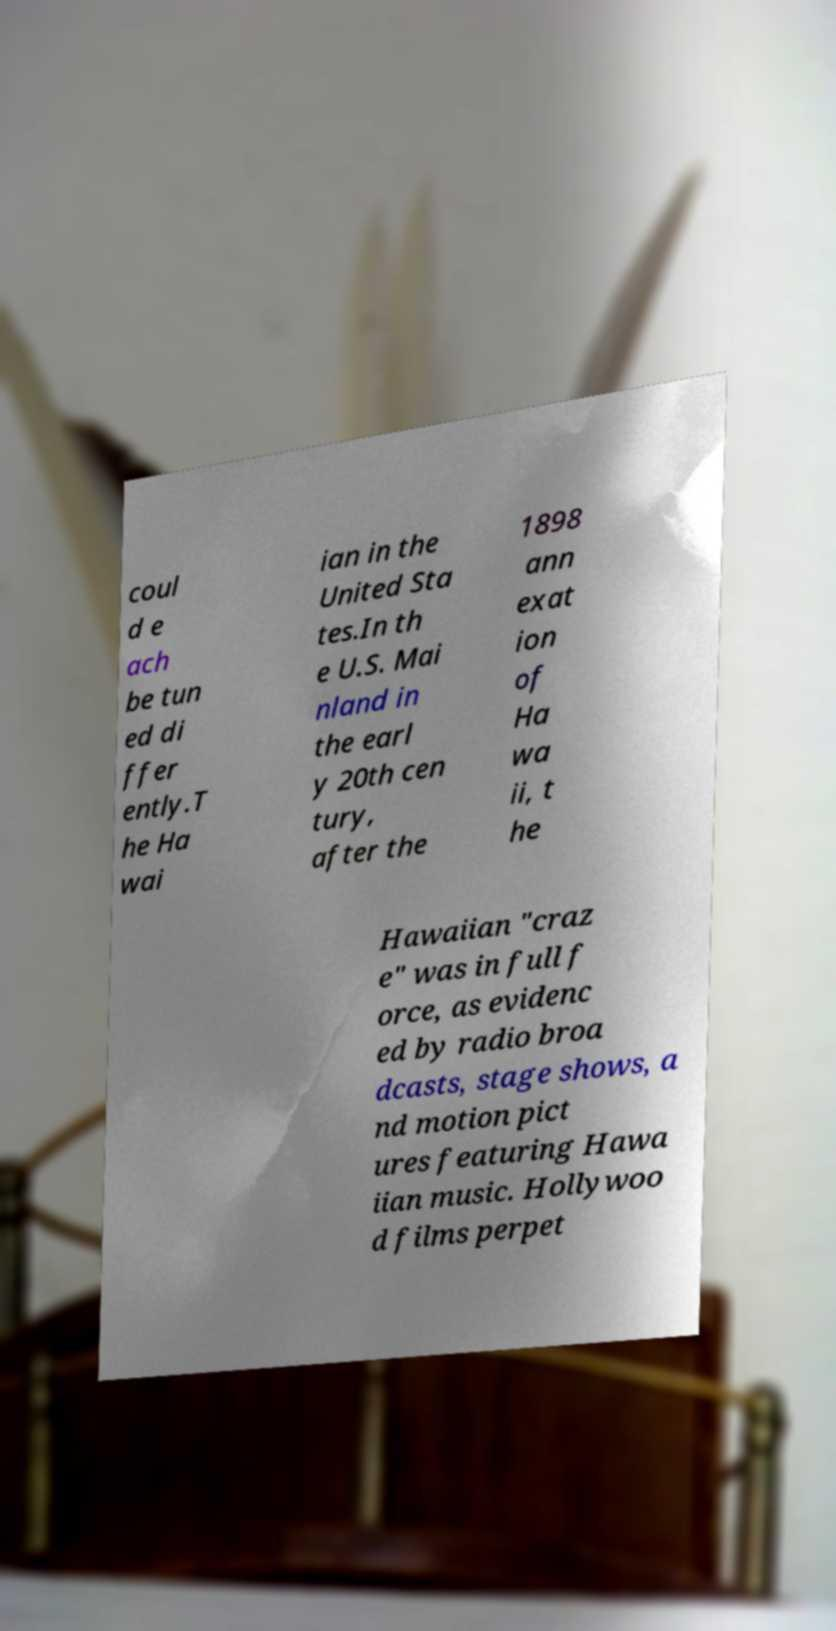I need the written content from this picture converted into text. Can you do that? coul d e ach be tun ed di ffer ently.T he Ha wai ian in the United Sta tes.In th e U.S. Mai nland in the earl y 20th cen tury, after the 1898 ann exat ion of Ha wa ii, t he Hawaiian "craz e" was in full f orce, as evidenc ed by radio broa dcasts, stage shows, a nd motion pict ures featuring Hawa iian music. Hollywoo d films perpet 